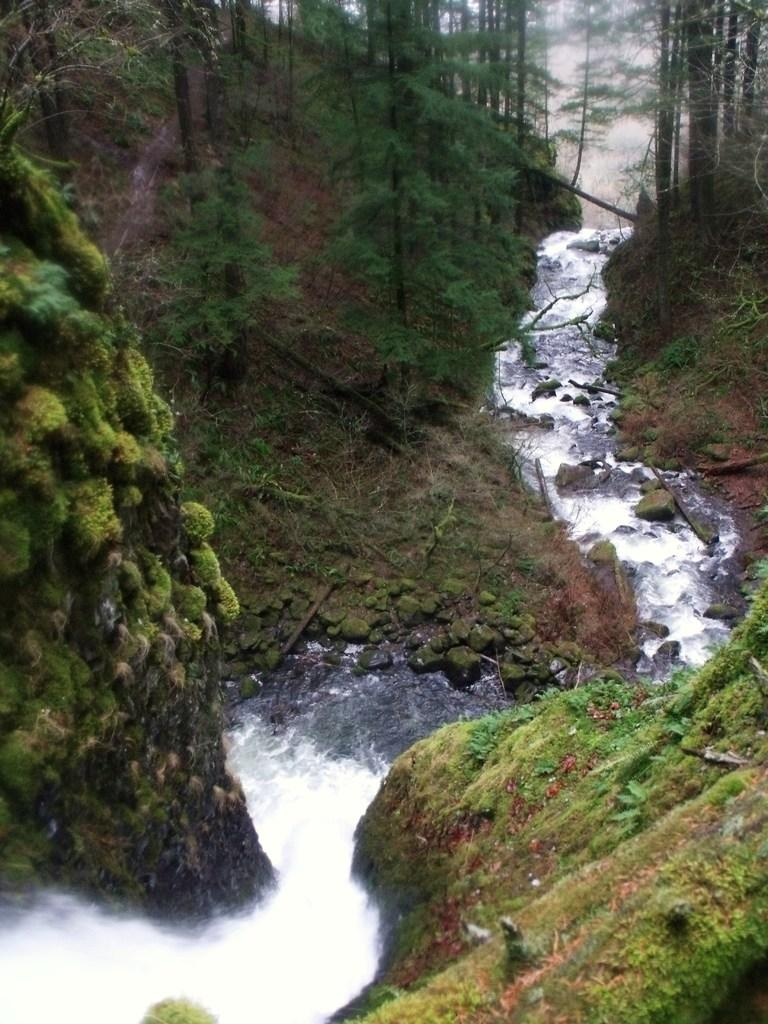What is happening on the ground in the image? Water is flowing on the ground in the image. What else can be seen on the ground besides the water? There are stones, grass, and trees on the ground in the image. Can you describe the rocks in the image? There are stones in the image, and grass is present on the rocks on both the left and right sides. What type of vegetation is visible in the image? Grass and trees are visible in the image. What type of road can be seen in the image? There is no road present in the image; it features water flowing on the ground, stones, grass, and trees. What achievements can be seen on the ground in the image? There are no achievements visible on the ground in the image; it features water flowing on the ground, stones, grass, and trees. 